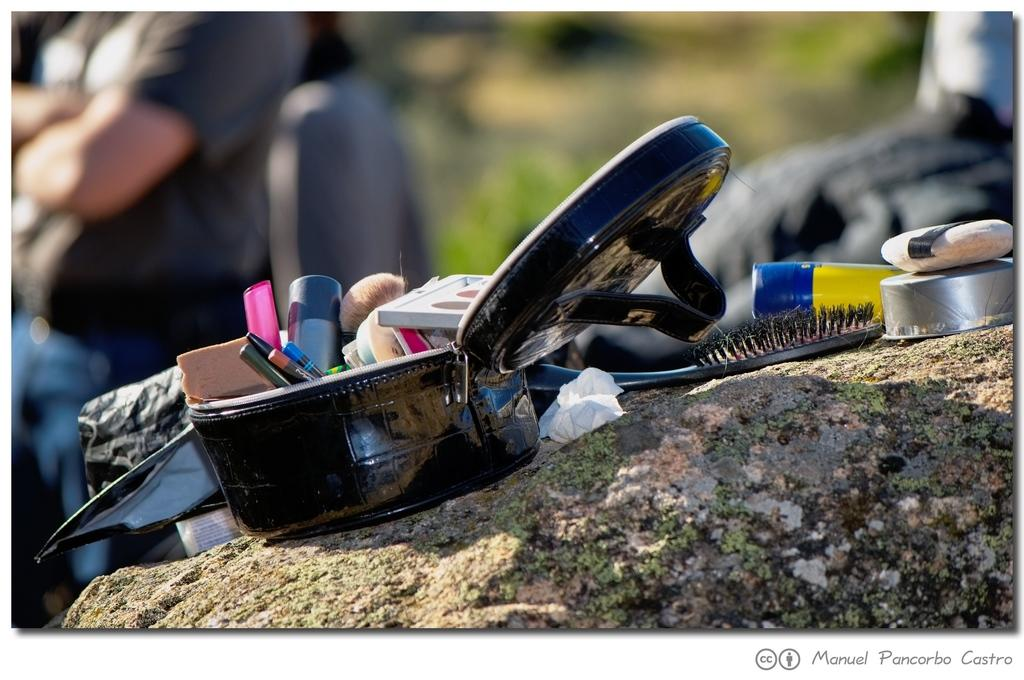What is present in the image? There is a bag in the image. Can you describe the bag? The bag is black. What can be found inside the bag? There are objects inside the bag. What can be seen in the background of the image? There are persons and trees with green color in the background of the image. What type of loaf can be seen in the image? There is no loaf present in the image. Can you tell me how many needles are visible in the image? There are no needles visible in the image. 